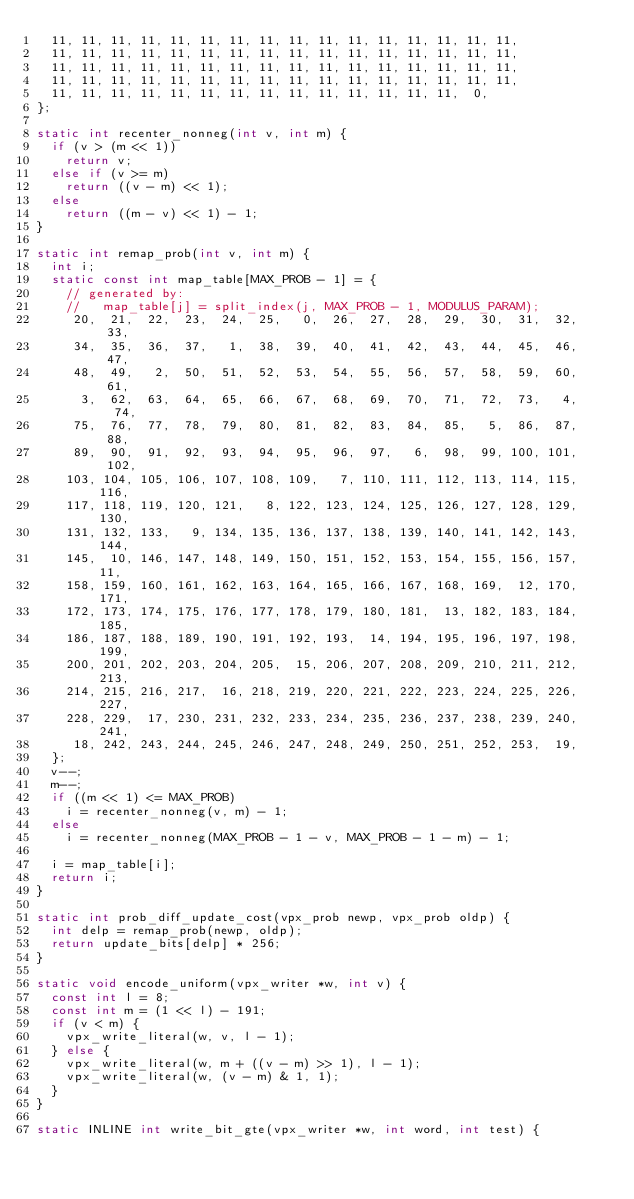Convert code to text. <code><loc_0><loc_0><loc_500><loc_500><_C_>  11, 11, 11, 11, 11, 11, 11, 11, 11, 11, 11, 11, 11, 11, 11, 11,
  11, 11, 11, 11, 11, 11, 11, 11, 11, 11, 11, 11, 11, 11, 11, 11,
  11, 11, 11, 11, 11, 11, 11, 11, 11, 11, 11, 11, 11, 11, 11, 11,
  11, 11, 11, 11, 11, 11, 11, 11, 11, 11, 11, 11, 11, 11, 11, 11,
  11, 11, 11, 11, 11, 11, 11, 11, 11, 11, 11, 11, 11, 11,  0,
};

static int recenter_nonneg(int v, int m) {
  if (v > (m << 1))
    return v;
  else if (v >= m)
    return ((v - m) << 1);
  else
    return ((m - v) << 1) - 1;
}

static int remap_prob(int v, int m) {
  int i;
  static const int map_table[MAX_PROB - 1] = {
    // generated by:
    //   map_table[j] = split_index(j, MAX_PROB - 1, MODULUS_PARAM);
     20,  21,  22,  23,  24,  25,   0,  26,  27,  28,  29,  30,  31,  32,  33,
     34,  35,  36,  37,   1,  38,  39,  40,  41,  42,  43,  44,  45,  46,  47,
     48,  49,   2,  50,  51,  52,  53,  54,  55,  56,  57,  58,  59,  60,  61,
      3,  62,  63,  64,  65,  66,  67,  68,  69,  70,  71,  72,  73,   4,  74,
     75,  76,  77,  78,  79,  80,  81,  82,  83,  84,  85,   5,  86,  87,  88,
     89,  90,  91,  92,  93,  94,  95,  96,  97,   6,  98,  99, 100, 101, 102,
    103, 104, 105, 106, 107, 108, 109,   7, 110, 111, 112, 113, 114, 115, 116,
    117, 118, 119, 120, 121,   8, 122, 123, 124, 125, 126, 127, 128, 129, 130,
    131, 132, 133,   9, 134, 135, 136, 137, 138, 139, 140, 141, 142, 143, 144,
    145,  10, 146, 147, 148, 149, 150, 151, 152, 153, 154, 155, 156, 157,  11,
    158, 159, 160, 161, 162, 163, 164, 165, 166, 167, 168, 169,  12, 170, 171,
    172, 173, 174, 175, 176, 177, 178, 179, 180, 181,  13, 182, 183, 184, 185,
    186, 187, 188, 189, 190, 191, 192, 193,  14, 194, 195, 196, 197, 198, 199,
    200, 201, 202, 203, 204, 205,  15, 206, 207, 208, 209, 210, 211, 212, 213,
    214, 215, 216, 217,  16, 218, 219, 220, 221, 222, 223, 224, 225, 226, 227,
    228, 229,  17, 230, 231, 232, 233, 234, 235, 236, 237, 238, 239, 240, 241,
     18, 242, 243, 244, 245, 246, 247, 248, 249, 250, 251, 252, 253,  19,
  };
  v--;
  m--;
  if ((m << 1) <= MAX_PROB)
    i = recenter_nonneg(v, m) - 1;
  else
    i = recenter_nonneg(MAX_PROB - 1 - v, MAX_PROB - 1 - m) - 1;

  i = map_table[i];
  return i;
}

static int prob_diff_update_cost(vpx_prob newp, vpx_prob oldp) {
  int delp = remap_prob(newp, oldp);
  return update_bits[delp] * 256;
}

static void encode_uniform(vpx_writer *w, int v) {
  const int l = 8;
  const int m = (1 << l) - 191;
  if (v < m) {
    vpx_write_literal(w, v, l - 1);
  } else {
    vpx_write_literal(w, m + ((v - m) >> 1), l - 1);
    vpx_write_literal(w, (v - m) & 1, 1);
  }
}

static INLINE int write_bit_gte(vpx_writer *w, int word, int test) {</code> 